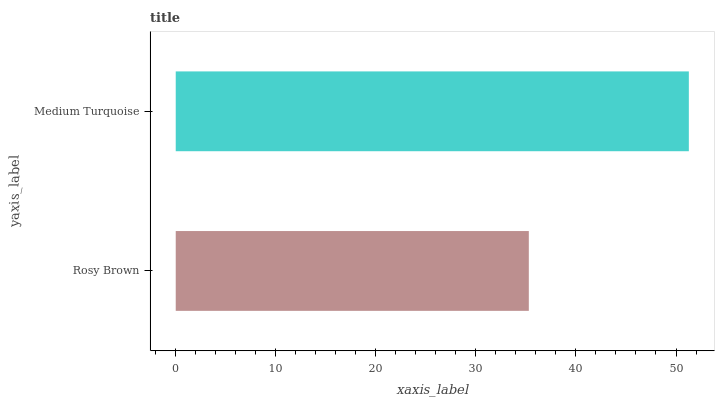Is Rosy Brown the minimum?
Answer yes or no. Yes. Is Medium Turquoise the maximum?
Answer yes or no. Yes. Is Medium Turquoise the minimum?
Answer yes or no. No. Is Medium Turquoise greater than Rosy Brown?
Answer yes or no. Yes. Is Rosy Brown less than Medium Turquoise?
Answer yes or no. Yes. Is Rosy Brown greater than Medium Turquoise?
Answer yes or no. No. Is Medium Turquoise less than Rosy Brown?
Answer yes or no. No. Is Medium Turquoise the high median?
Answer yes or no. Yes. Is Rosy Brown the low median?
Answer yes or no. Yes. Is Rosy Brown the high median?
Answer yes or no. No. Is Medium Turquoise the low median?
Answer yes or no. No. 